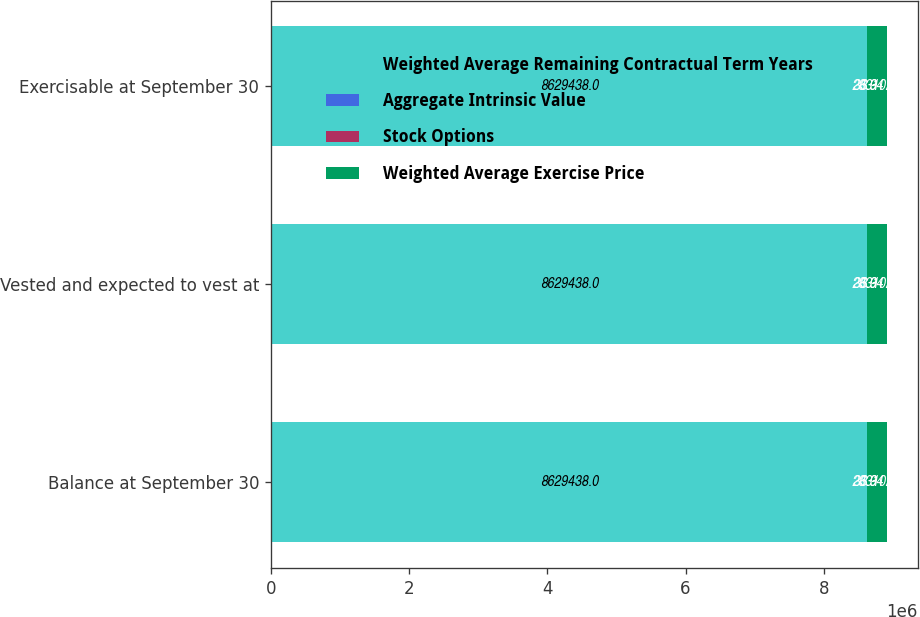<chart> <loc_0><loc_0><loc_500><loc_500><stacked_bar_chart><ecel><fcel>Balance at September 30<fcel>Vested and expected to vest at<fcel>Exercisable at September 30<nl><fcel>Weighted Average Remaining Contractual Term Years<fcel>8.62944e+06<fcel>8.62944e+06<fcel>8.62944e+06<nl><fcel>Aggregate Intrinsic Value<fcel>36.94<fcel>36.94<fcel>36.94<nl><fcel>Stock Options<fcel>3.3<fcel>3.3<fcel>3.3<nl><fcel>Weighted Average Exercise Price<fcel>283102<fcel>283102<fcel>283102<nl></chart> 